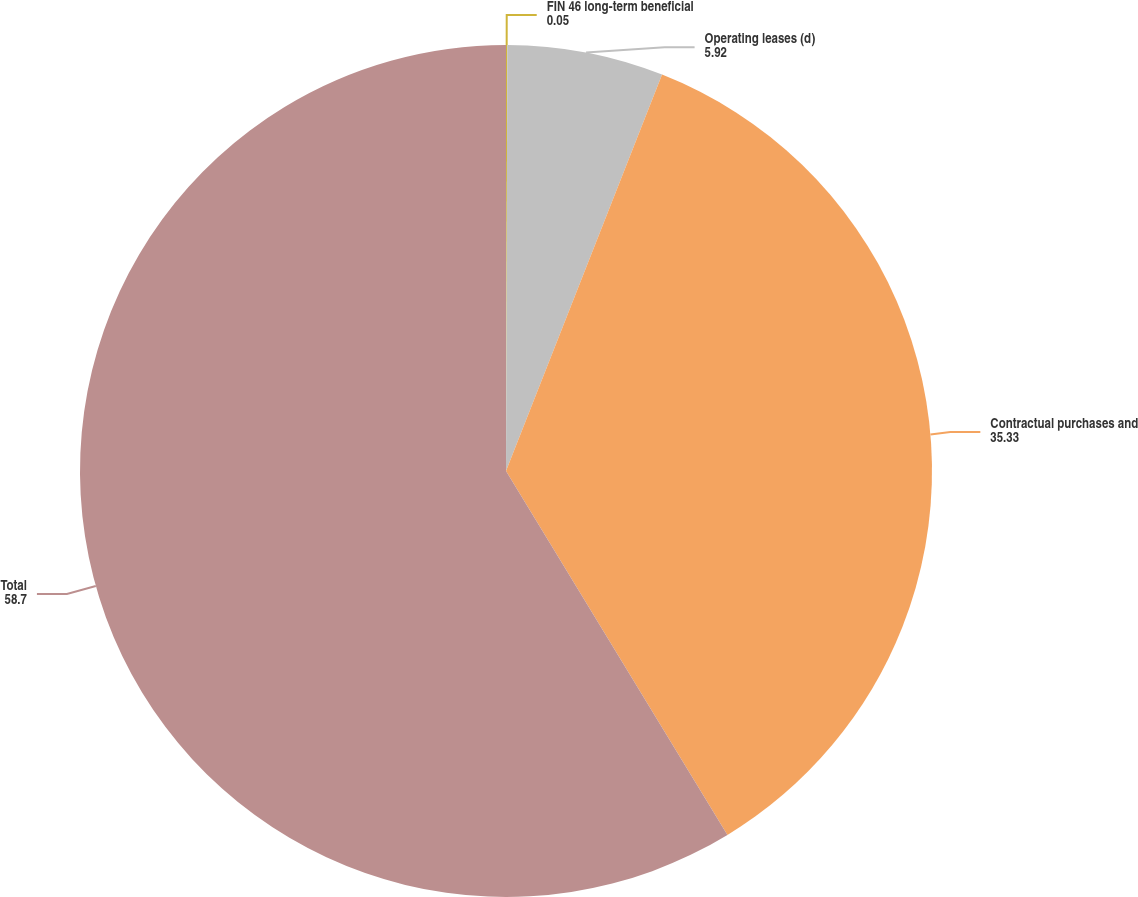Convert chart. <chart><loc_0><loc_0><loc_500><loc_500><pie_chart><fcel>FIN 46 long-term beneficial<fcel>Operating leases (d)<fcel>Contractual purchases and<fcel>Total<nl><fcel>0.05%<fcel>5.92%<fcel>35.33%<fcel>58.7%<nl></chart> 